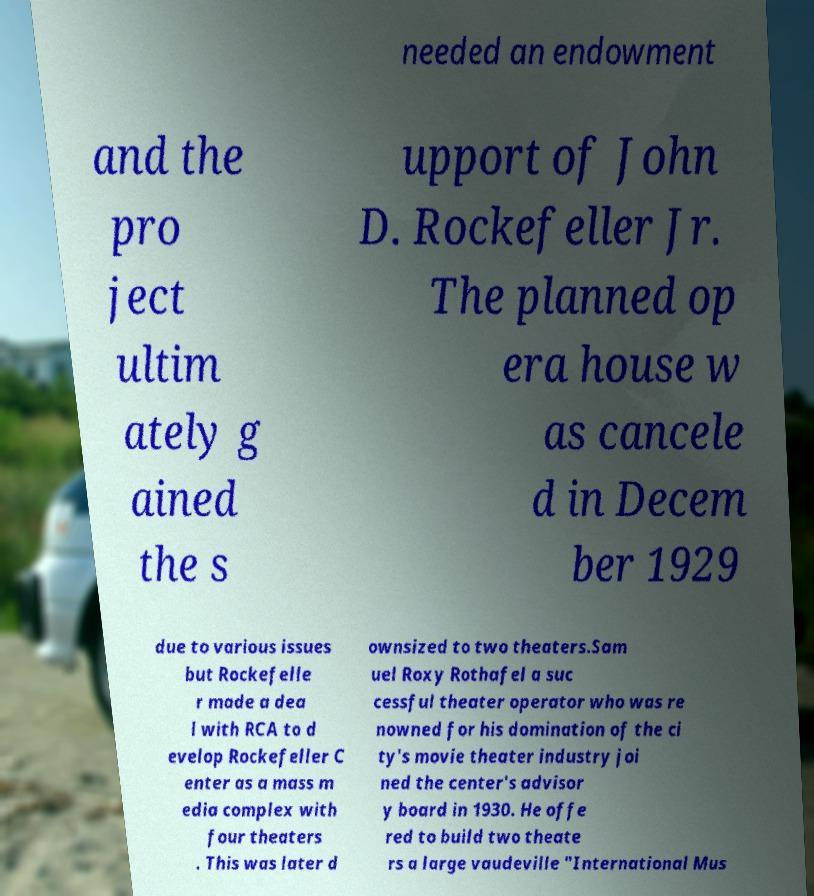What messages or text are displayed in this image? I need them in a readable, typed format. needed an endowment and the pro ject ultim ately g ained the s upport of John D. Rockefeller Jr. The planned op era house w as cancele d in Decem ber 1929 due to various issues but Rockefelle r made a dea l with RCA to d evelop Rockefeller C enter as a mass m edia complex with four theaters . This was later d ownsized to two theaters.Sam uel Roxy Rothafel a suc cessful theater operator who was re nowned for his domination of the ci ty's movie theater industry joi ned the center's advisor y board in 1930. He offe red to build two theate rs a large vaudeville "International Mus 